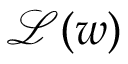<formula> <loc_0><loc_0><loc_500><loc_500>\mathcal { L } ( w )</formula> 